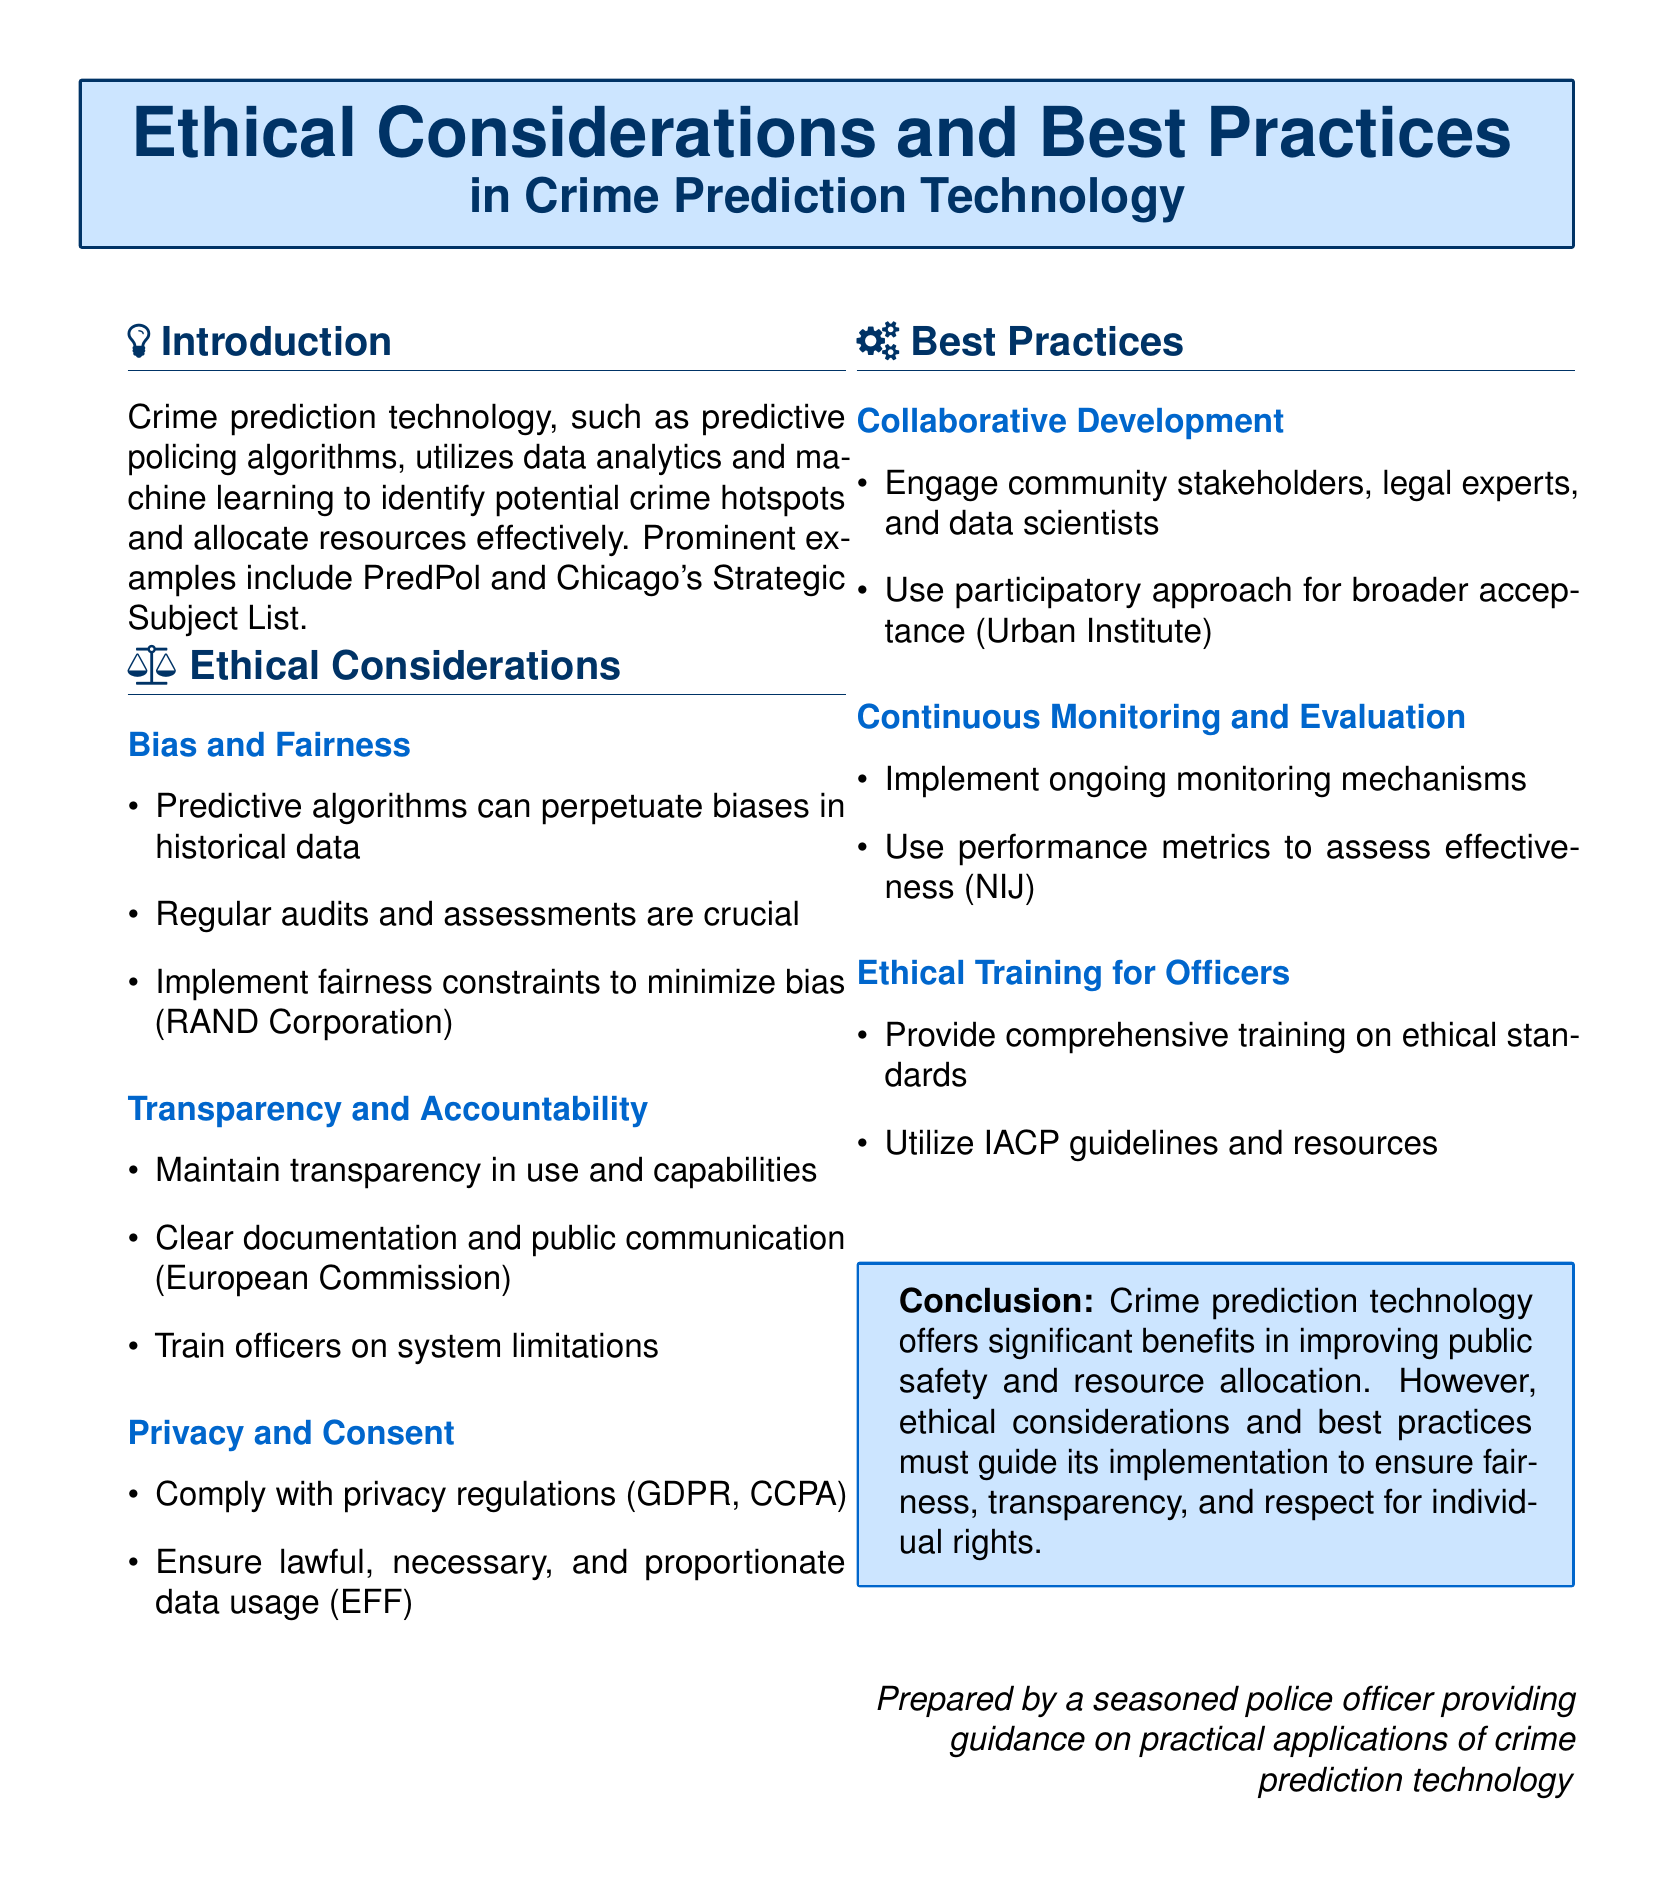What is the main topic of the flyer? The flyer discusses Ethical Considerations and Best Practices in Crime Prediction Technology.
Answer: Ethical Considerations and Best Practices in Crime Prediction Technology What type of algorithms are mentioned as examples? The document refers to predictive policing algorithms like PredPol and Chicago's Strategic Subject List.
Answer: PredPol and Chicago's Strategic Subject List What is one ethical consideration related to predictive algorithms? The flyer highlights the need to address bias in historical data concerning predictive algorithms.
Answer: Bias and Fairness What should be implemented to minimize bias according to the document? It recommends implementing fairness constraints to minimize bias.
Answer: Fairness constraints Which organization is mentioned regarding transparency and accountability? The European Commission is referenced in the context of maintaining transparency in the use of predictive technology.
Answer: European Commission What is an essential practice for the continuous evaluation of crime prediction technology? It emphasizes the need for ongoing monitoring and the use of performance metrics.
Answer: Ongoing monitoring Who needs to be engaged in the collaborative development of crime prediction tools? Community stakeholders, legal experts, and data scientists should be engaged.
Answer: Community stakeholders, legal experts, and data scientists What is the conclusion expressed in the flyer? The conclusion states that ethical considerations must guide the implementation of crime prediction technology.
Answer: Ethical considerations must guide the implementation What type of training is mentioned for officers? The document states that comprehensive ethical training is necessary for officers.
Answer: Comprehensive ethical training 